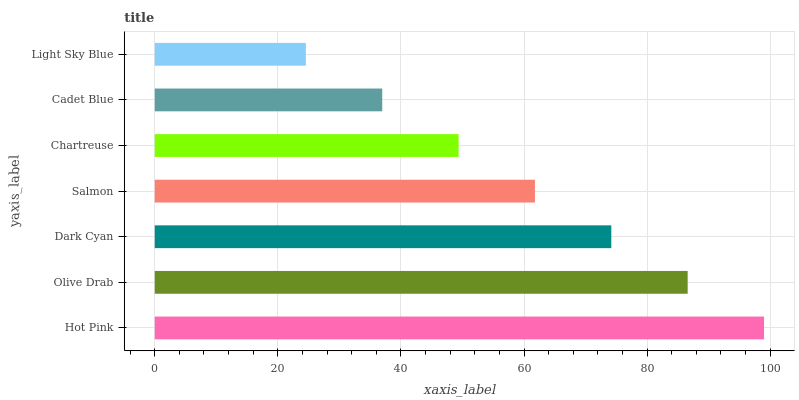Is Light Sky Blue the minimum?
Answer yes or no. Yes. Is Hot Pink the maximum?
Answer yes or no. Yes. Is Olive Drab the minimum?
Answer yes or no. No. Is Olive Drab the maximum?
Answer yes or no. No. Is Hot Pink greater than Olive Drab?
Answer yes or no. Yes. Is Olive Drab less than Hot Pink?
Answer yes or no. Yes. Is Olive Drab greater than Hot Pink?
Answer yes or no. No. Is Hot Pink less than Olive Drab?
Answer yes or no. No. Is Salmon the high median?
Answer yes or no. Yes. Is Salmon the low median?
Answer yes or no. Yes. Is Light Sky Blue the high median?
Answer yes or no. No. Is Light Sky Blue the low median?
Answer yes or no. No. 